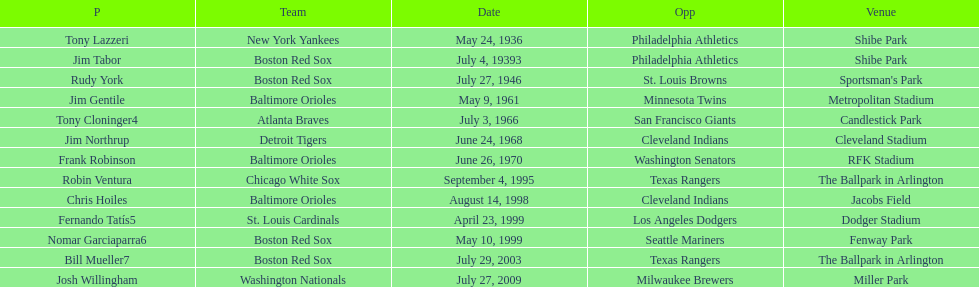What was the name of the player who accomplished this in 1999 but played for the boston red sox? Nomar Garciaparra. 